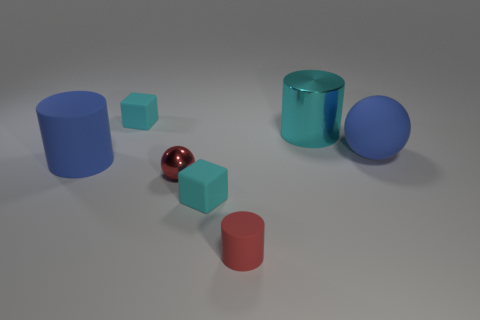There is a blue thing left of the small red cylinder; does it have the same size as the rubber cube in front of the metallic cylinder?
Provide a short and direct response. No. There is a cyan rubber cube in front of the blue object left of the blue rubber thing that is to the right of the small red cylinder; how big is it?
Your answer should be compact. Small. What shape is the cyan matte object right of the rubber cube behind the large cyan cylinder?
Your answer should be compact. Cube. There is a object that is to the right of the big cyan metallic cylinder; is it the same color as the tiny metallic object?
Your answer should be compact. No. There is a big thing that is on the right side of the red matte object and in front of the cyan cylinder; what color is it?
Provide a short and direct response. Blue. Are there any blocks that have the same material as the big cyan thing?
Keep it short and to the point. No. What is the size of the red metal ball?
Give a very brief answer. Small. How big is the matte block that is in front of the big matte thing right of the red metal ball?
Give a very brief answer. Small. What is the material of the big cyan object that is the same shape as the tiny red matte thing?
Your response must be concise. Metal. How many gray cylinders are there?
Provide a succinct answer. 0. 